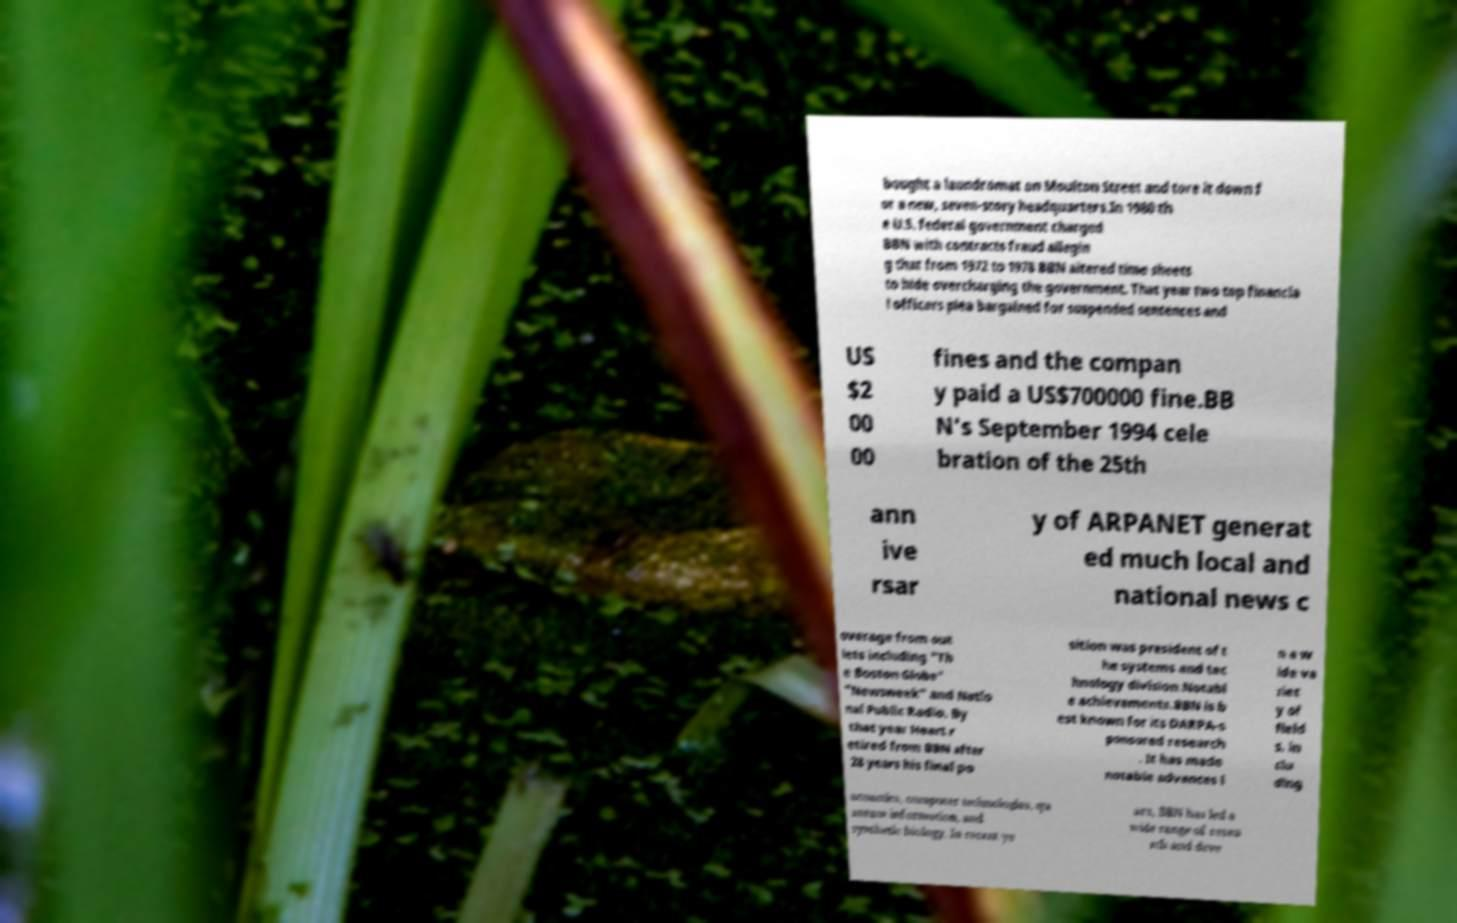Could you assist in decoding the text presented in this image and type it out clearly? bought a laundromat on Moulton Street and tore it down f or a new, seven-story headquarters.In 1980 th e U.S. federal government charged BBN with contracts fraud allegin g that from 1972 to 1978 BBN altered time sheets to hide overcharging the government. That year two top financia l officers plea bargained for suspended sentences and US $2 00 00 fines and the compan y paid a US$700000 fine.BB N's September 1994 cele bration of the 25th ann ive rsar y of ARPANET generat ed much local and national news c overage from out lets including "Th e Boston Globe" "Newsweek" and Natio nal Public Radio. By that year Heart r etired from BBN after 28 years his final po sition was president of t he systems and tec hnology division.Notabl e achievements.BBN is b est known for its DARPA-s ponsored research . It has made notable advances i n a w ide va riet y of field s, in clu ding acoustics, computer technologies, qu antum information, and synthetic biology. In recent ye ars, BBN has led a wide range of resea rch and deve 